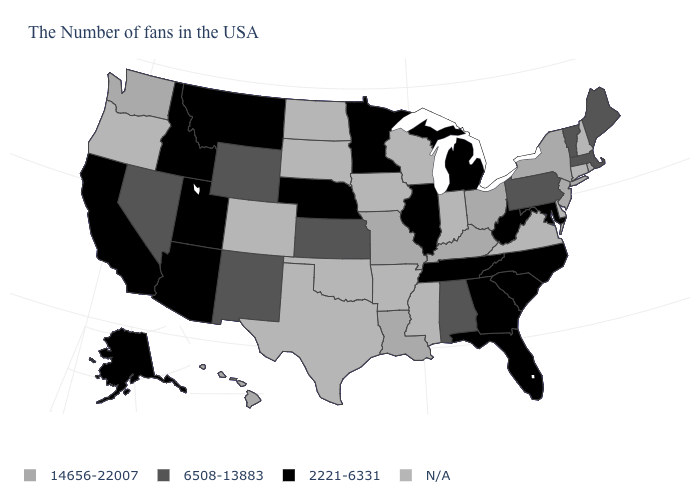Name the states that have a value in the range 6508-13883?
Write a very short answer. Maine, Massachusetts, Vermont, Pennsylvania, Alabama, Kansas, Wyoming, New Mexico, Nevada. What is the value of New Hampshire?
Concise answer only. N/A. Does the map have missing data?
Answer briefly. Yes. What is the value of Alaska?
Keep it brief. 2221-6331. What is the value of Illinois?
Short answer required. 2221-6331. What is the lowest value in the USA?
Quick response, please. 2221-6331. Name the states that have a value in the range 2221-6331?
Give a very brief answer. Maryland, North Carolina, South Carolina, West Virginia, Florida, Georgia, Michigan, Tennessee, Illinois, Minnesota, Nebraska, Utah, Montana, Arizona, Idaho, California, Alaska. What is the highest value in the USA?
Short answer required. 14656-22007. What is the value of Washington?
Write a very short answer. 14656-22007. Which states have the lowest value in the USA?
Concise answer only. Maryland, North Carolina, South Carolina, West Virginia, Florida, Georgia, Michigan, Tennessee, Illinois, Minnesota, Nebraska, Utah, Montana, Arizona, Idaho, California, Alaska. How many symbols are there in the legend?
Write a very short answer. 4. What is the lowest value in states that border Alabama?
Answer briefly. 2221-6331. Name the states that have a value in the range 14656-22007?
Quick response, please. Rhode Island, New York, New Jersey, Ohio, Kentucky, Louisiana, Missouri, Washington, Hawaii. What is the lowest value in the MidWest?
Concise answer only. 2221-6331. Does the first symbol in the legend represent the smallest category?
Be succinct. No. 